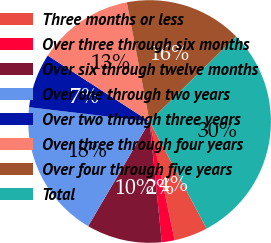Convert chart to OTSL. <chart><loc_0><loc_0><loc_500><loc_500><pie_chart><fcel>Three months or less<fcel>Over three through six months<fcel>Over six through twelve months<fcel>Over one through two years<fcel>Over two through three years<fcel>Over three through four years<fcel>Over four through five years<fcel>Total<nl><fcel>4.48%<fcel>1.7%<fcel>10.06%<fcel>18.43%<fcel>7.27%<fcel>12.85%<fcel>15.64%<fcel>29.58%<nl></chart> 